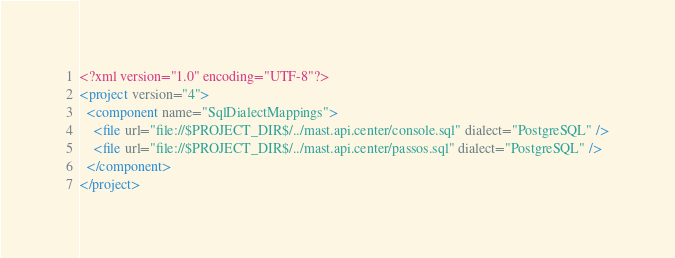<code> <loc_0><loc_0><loc_500><loc_500><_XML_><?xml version="1.0" encoding="UTF-8"?>
<project version="4">
  <component name="SqlDialectMappings">
    <file url="file://$PROJECT_DIR$/../mast.api.center/console.sql" dialect="PostgreSQL" />
    <file url="file://$PROJECT_DIR$/../mast.api.center/passos.sql" dialect="PostgreSQL" />
  </component>
</project></code> 